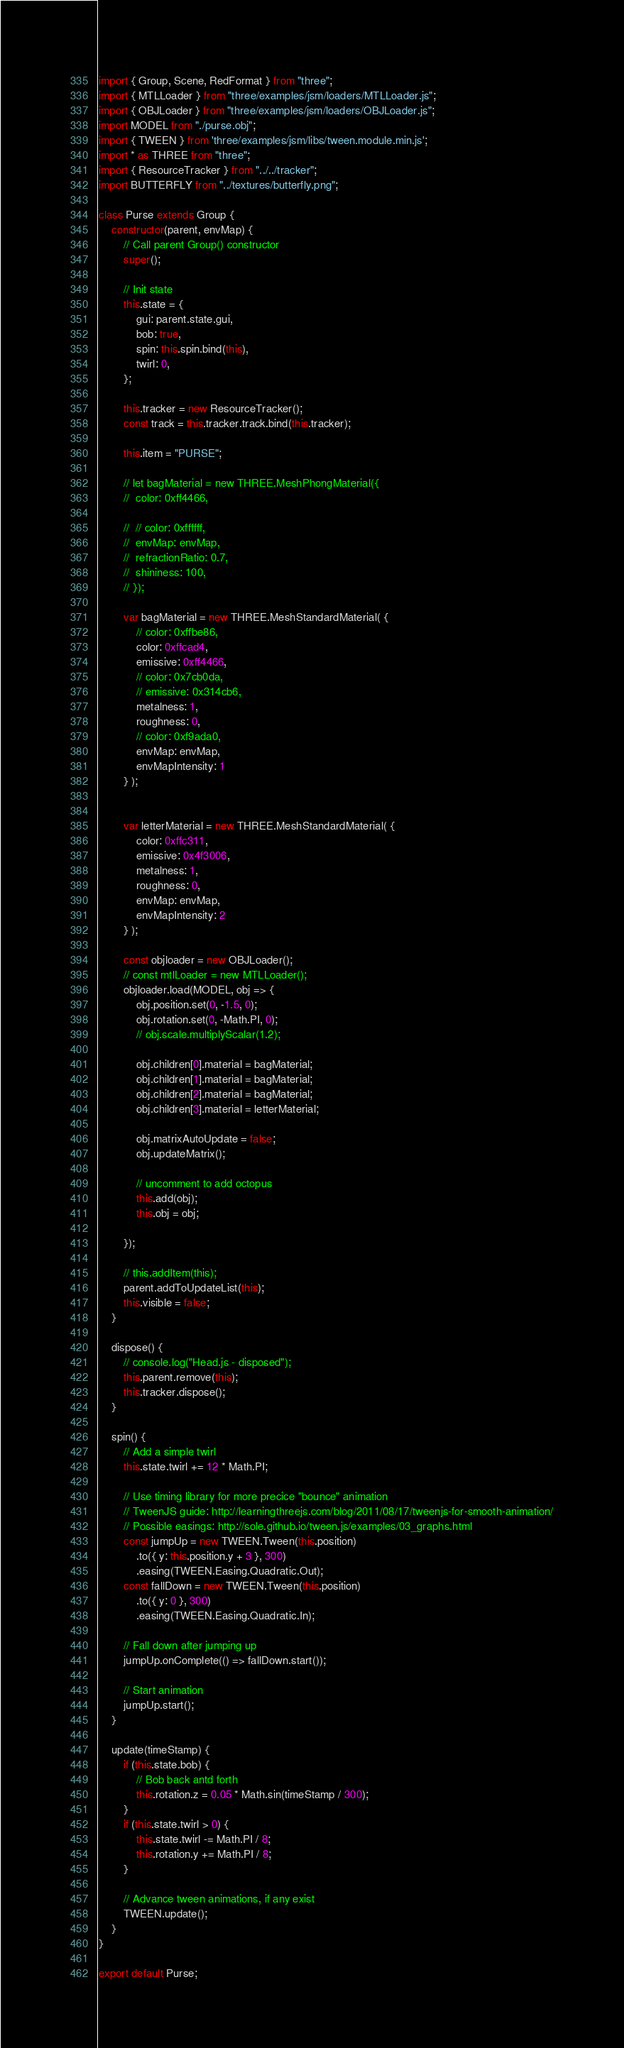<code> <loc_0><loc_0><loc_500><loc_500><_JavaScript_>import { Group, Scene, RedFormat } from "three";
import { MTLLoader } from "three/examples/jsm/loaders/MTLLoader.js";
import { OBJLoader } from "three/examples/jsm/loaders/OBJLoader.js";
import MODEL from "./purse.obj";
import { TWEEN } from 'three/examples/jsm/libs/tween.module.min.js';
import * as THREE from "three";
import { ResourceTracker } from "../../tracker";
import BUTTERFLY from "../textures/butterfly.png";

class Purse extends Group {
	constructor(parent, envMap) {
		// Call parent Group() constructor
		super();

		// Init state
		this.state = {
			gui: parent.state.gui,
			bob: true,
			spin: this.spin.bind(this),
			twirl: 0,
		};

		this.tracker = new ResourceTracker();
		const track = this.tracker.track.bind(this.tracker);

		this.item = "PURSE";

		// let bagMaterial = new THREE.MeshPhongMaterial({
		// 	color: 0xff4466,

		// 	// color: 0xffffff,
		// 	envMap: envMap,
		// 	refractionRatio: 0.7,
		// 	shininess: 100,
        // });
        
        var bagMaterial = new THREE.MeshStandardMaterial( {
			// color: 0xffbe86,
			color: 0xffcad4,
			emissive: 0xff4466,
			// color: 0x7cb0da,
			// emissive: 0x314cb6,
            metalness: 1,
            roughness: 0,
            // color: 0xf9ada0,
            envMap: envMap,
            envMapIntensity: 1
        } );
	

        var letterMaterial = new THREE.MeshStandardMaterial( {
			color: 0xffc311,
			emissive: 0x4f3006,
			metalness: 1,
            roughness: 0,
			envMap: envMap,
            envMapIntensity: 2
        } );
	
		const objloader = new OBJLoader();
		// const mtlLoader = new MTLLoader();
		objloader.load(MODEL, obj => {
			obj.position.set(0, -1.5, 0);
			obj.rotation.set(0, -Math.PI, 0);
			// obj.scale.multiplyScalar(1.2);

			obj.children[0].material = bagMaterial;
			obj.children[1].material = bagMaterial;
			obj.children[2].material = bagMaterial;
			obj.children[3].material = letterMaterial;

			obj.matrixAutoUpdate = false;
			obj.updateMatrix();
			
			// uncomment to add octopus
			this.add(obj);
			this.obj = obj;

		});

		// this.addItem(this);
		parent.addToUpdateList(this);
		this.visible = false;
	}

	dispose() {
		// console.log("Head.js - disposed");
        this.parent.remove(this);
        this.tracker.dispose();
    }

	spin() {
		// Add a simple twirl
		this.state.twirl += 12 * Math.PI;

		// Use timing library for more precice "bounce" animation
		// TweenJS guide: http://learningthreejs.com/blog/2011/08/17/tweenjs-for-smooth-animation/
		// Possible easings: http://sole.github.io/tween.js/examples/03_graphs.html
		const jumpUp = new TWEEN.Tween(this.position)
			.to({ y: this.position.y + 3 }, 300)
			.easing(TWEEN.Easing.Quadratic.Out);
		const fallDown = new TWEEN.Tween(this.position)
			.to({ y: 0 }, 300)
			.easing(TWEEN.Easing.Quadratic.In);

		// Fall down after jumping up
		jumpUp.onComplete(() => fallDown.start());

		// Start animation
		jumpUp.start();
	}

	update(timeStamp) {
        if (this.state.bob) {
            // Bob back antd forth
            this.rotation.z = 0.05 * Math.sin(timeStamp / 300);
        }
        if (this.state.twirl > 0) {
            this.state.twirl -= Math.PI / 8;
            this.rotation.y += Math.PI / 8;
        }

        // Advance tween animations, if any exist
        TWEEN.update();
	}
}

export default Purse;
</code> 